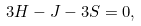<formula> <loc_0><loc_0><loc_500><loc_500>3 H - J - 3 S = 0 ,</formula> 